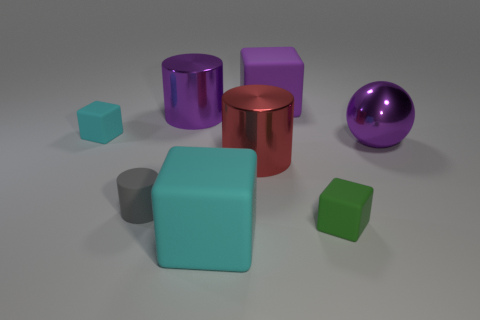Subtract 1 blocks. How many blocks are left? 3 Add 1 big green shiny cylinders. How many objects exist? 9 Subtract all cylinders. How many objects are left? 5 Add 2 blocks. How many blocks exist? 6 Subtract 0 blue spheres. How many objects are left? 8 Subtract all large purple objects. Subtract all shiny cylinders. How many objects are left? 3 Add 5 gray matte cylinders. How many gray matte cylinders are left? 6 